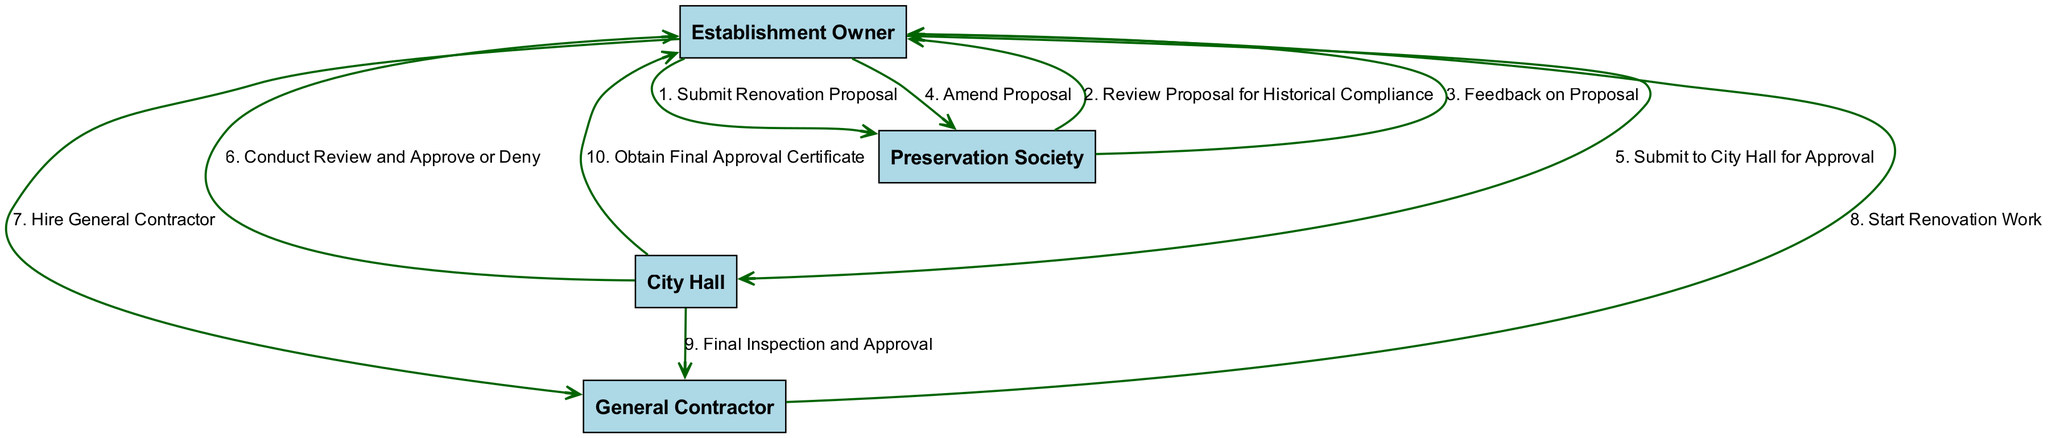What is the first action in the renovation process? The first action indicated in the diagram is "Submit Renovation Proposal," which is performed by the Establishment Owner directed to the Preservation Society.
Answer: Submit Renovation Proposal How many participants are involved in the process? The diagram shows a total of four participants: Establishment Owner, Preservation Society, City Hall, and General Contractor.
Answer: Four What is the last action taken in the process? The last action in the sequence is "Obtain Final Approval Certificate," executed by City Hall and directed to the Establishment Owner.
Answer: Obtain Final Approval Certificate Which step does the City Hall conduct after the Establishment Owner submits to them? After submission from the Establishment Owner, City Hall conducts a review and either approves or denies the proposal, which is the sixth step mentioned in the diagram.
Answer: Conduct Review and Approve or Deny Who gives feedback on the proposal? The Preservation Society is responsible for providing feedback on the proposal to the Establishment Owner after their review for historical compliance.
Answer: Preservation Society In which step does the Establishment Owner hire the General Contractor? The Establishment Owner hires the General Contractor in the seventh step, following the approval from City Hall.
Answer: Hire General Contractor What action occurs between "Amend Proposal" and "Submit to City Hall for Approval"? Following the action "Amend Proposal," the Establishment Owner submits the amended proposal to City Hall for approval as the next step in the process flow.
Answer: Submit to City Hall for Approval Which actor is responsible for the final inspection? The final inspection is conducted by City Hall, which is the ninth step in the diagram where they inspect the work performed by the General Contractor.
Answer: City Hall How many actions are taken before hiring the General Contractor? There are six actions (from step 1 to step 6) taken before the Establishment Owner hires the General Contractor in step 7.
Answer: Six 